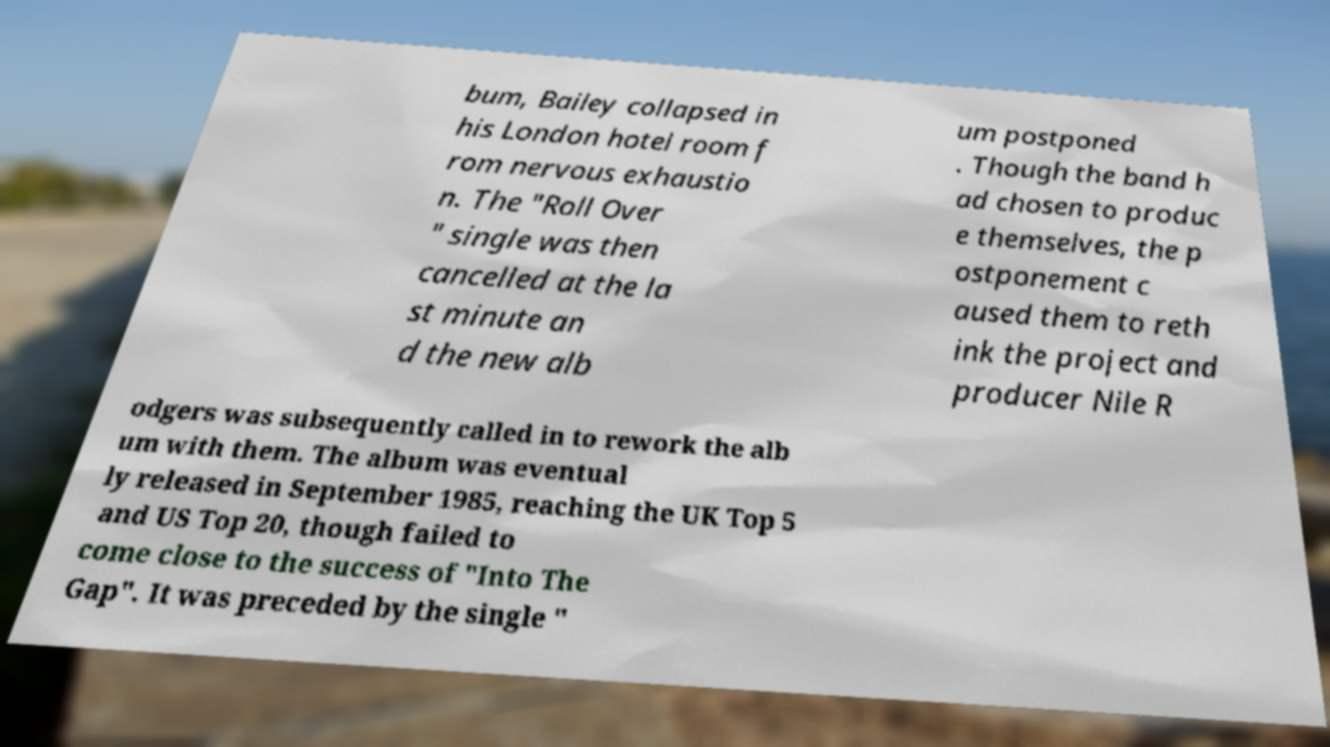What messages or text are displayed in this image? I need them in a readable, typed format. bum, Bailey collapsed in his London hotel room f rom nervous exhaustio n. The "Roll Over " single was then cancelled at the la st minute an d the new alb um postponed . Though the band h ad chosen to produc e themselves, the p ostponement c aused them to reth ink the project and producer Nile R odgers was subsequently called in to rework the alb um with them. The album was eventual ly released in September 1985, reaching the UK Top 5 and US Top 20, though failed to come close to the success of "Into The Gap". It was preceded by the single " 